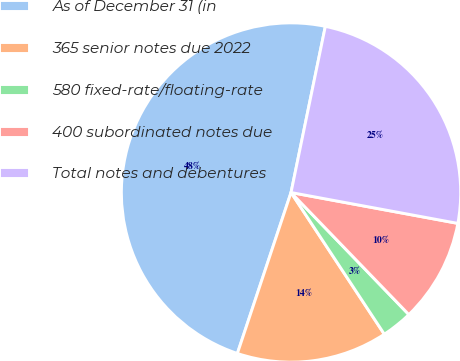Convert chart. <chart><loc_0><loc_0><loc_500><loc_500><pie_chart><fcel>As of December 31 (in<fcel>365 senior notes due 2022<fcel>580 fixed-rate/floating-rate<fcel>400 subordinated notes due<fcel>Total notes and debentures<nl><fcel>48.12%<fcel>14.39%<fcel>2.95%<fcel>9.87%<fcel>24.67%<nl></chart> 